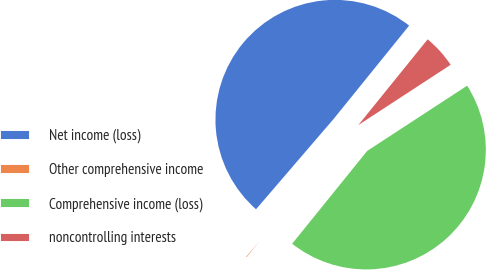Convert chart. <chart><loc_0><loc_0><loc_500><loc_500><pie_chart><fcel>Net income (loss)<fcel>Other comprehensive income<fcel>Comprehensive income (loss)<fcel>noncontrolling interests<nl><fcel>49.53%<fcel>0.47%<fcel>45.03%<fcel>4.97%<nl></chart> 